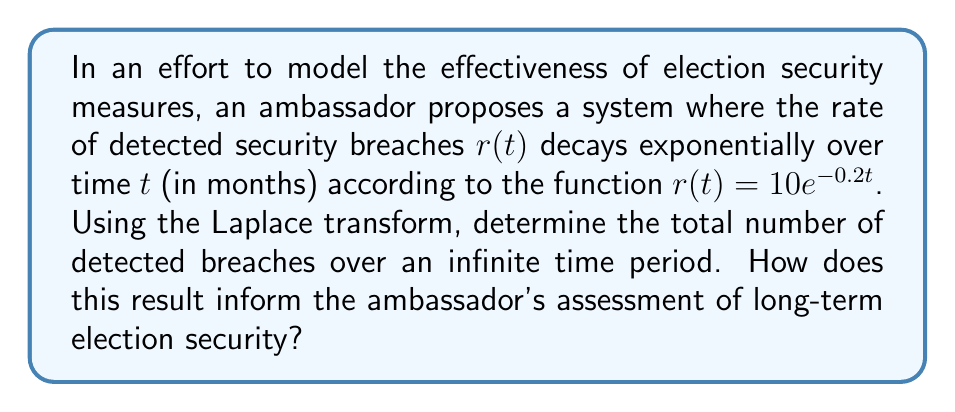Help me with this question. To solve this problem, we'll use the Laplace transform and its properties. Let's approach this step-by-step:

1) The Laplace transform of $r(t) = 10e^{-0.2t}$ is given by:

   $$\mathcal{L}\{r(t)\} = \int_0^\infty 10e^{-0.2t} e^{-st} dt = \frac{10}{s + 0.2}$$

2) To find the total number of detected breaches over an infinite time period, we need to integrate $r(t)$ from 0 to infinity:

   $$\int_0^\infty r(t) dt$$

3) This is equivalent to finding the Laplace transform of $r(t)$ and evaluating it at $s = 0$:

   $$\int_0^\infty r(t) dt = \lim_{s \to 0} \mathcal{L}\{r(t)\}$$

4) Substituting our Laplace transform:

   $$\lim_{s \to 0} \frac{10}{s + 0.2} = \frac{10}{0 + 0.2} = 50$$

5) Therefore, the total number of detected breaches over an infinite time period is 50.

This result informs the ambassador's assessment in several ways:
- It provides a finite number for an infinite time period, suggesting that the security measures are effective in limiting breaches over the long term.
- The value of 50 total breaches can be compared to other models or real-world data to assess the effectiveness of the current security measures.
- The exponential decay model implies that breaches become less frequent over time, which could indicate improving security or decreasing attempts by adversaries.
Answer: The total number of detected breaches over an infinite time period is 50. 